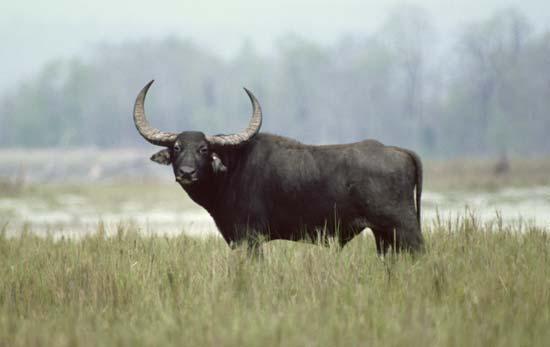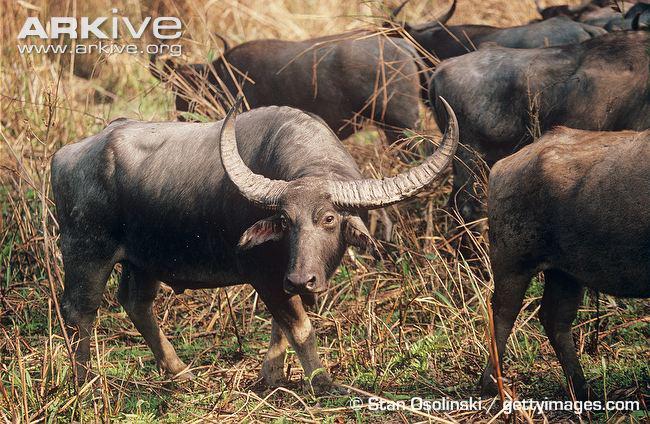The first image is the image on the left, the second image is the image on the right. For the images shown, is this caption "One of the images contains an animal that is not a water buffalo." true? Answer yes or no. No. The first image is the image on the left, the second image is the image on the right. Assess this claim about the two images: "There are at least five water buffalo.". Correct or not? Answer yes or no. Yes. 